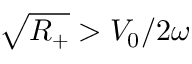<formula> <loc_0><loc_0><loc_500><loc_500>\sqrt { R _ { + } } > V _ { 0 } / 2 \omega</formula> 